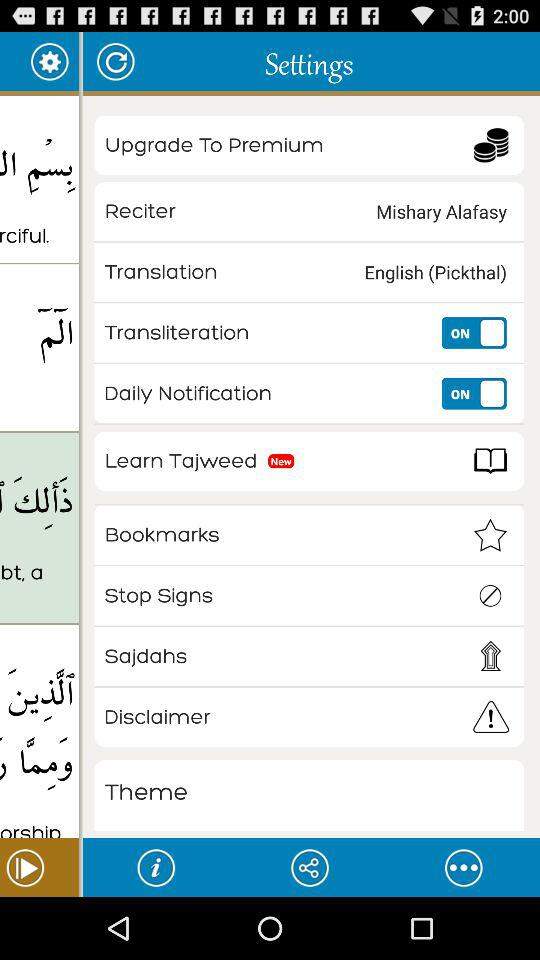What is the new option in the settings? The new option in the settings is "Learn Tajweed". 